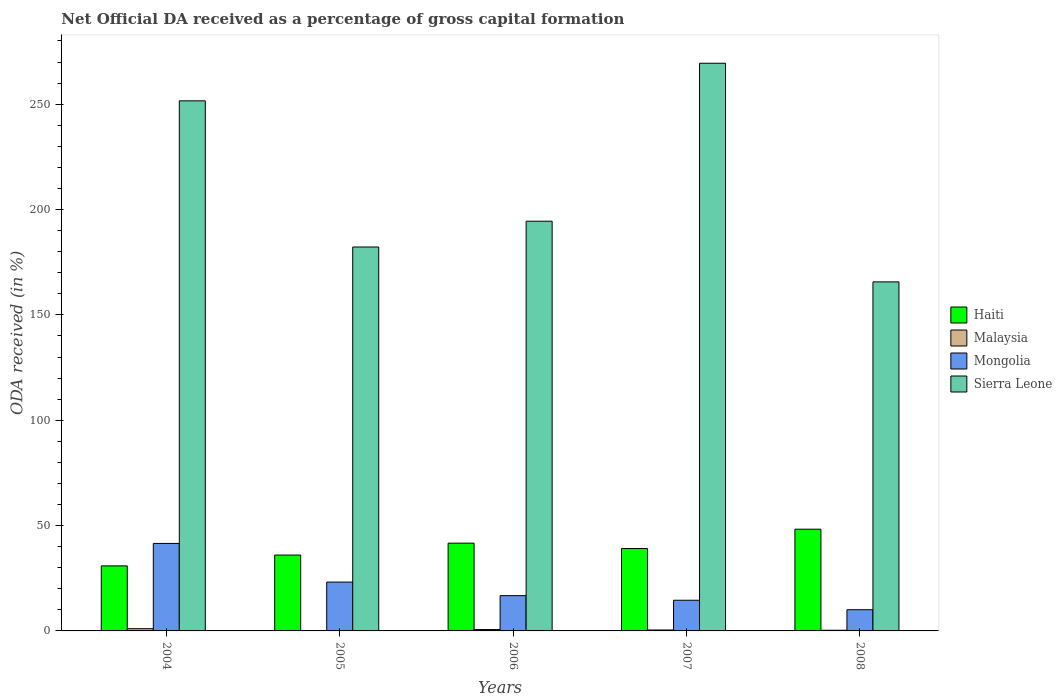How many bars are there on the 1st tick from the left?
Your response must be concise. 4. What is the label of the 3rd group of bars from the left?
Provide a succinct answer. 2006. What is the net ODA received in Mongolia in 2004?
Keep it short and to the point. 41.53. Across all years, what is the maximum net ODA received in Malaysia?
Your response must be concise. 1.06. Across all years, what is the minimum net ODA received in Malaysia?
Your response must be concise. 0.08. In which year was the net ODA received in Mongolia maximum?
Your answer should be very brief. 2004. In which year was the net ODA received in Malaysia minimum?
Provide a short and direct response. 2005. What is the total net ODA received in Sierra Leone in the graph?
Offer a terse response. 1063.39. What is the difference between the net ODA received in Malaysia in 2004 and that in 2007?
Ensure brevity in your answer.  0.62. What is the difference between the net ODA received in Malaysia in 2008 and the net ODA received in Haiti in 2004?
Give a very brief answer. -30.55. What is the average net ODA received in Sierra Leone per year?
Give a very brief answer. 212.68. In the year 2007, what is the difference between the net ODA received in Mongolia and net ODA received in Sierra Leone?
Offer a terse response. -254.87. What is the ratio of the net ODA received in Haiti in 2005 to that in 2006?
Your response must be concise. 0.86. Is the net ODA received in Malaysia in 2005 less than that in 2007?
Your response must be concise. Yes. Is the difference between the net ODA received in Mongolia in 2005 and 2006 greater than the difference between the net ODA received in Sierra Leone in 2005 and 2006?
Offer a very short reply. Yes. What is the difference between the highest and the second highest net ODA received in Haiti?
Your answer should be very brief. 6.62. What is the difference between the highest and the lowest net ODA received in Haiti?
Give a very brief answer. 17.42. In how many years, is the net ODA received in Malaysia greater than the average net ODA received in Malaysia taken over all years?
Your answer should be compact. 2. Is the sum of the net ODA received in Malaysia in 2005 and 2007 greater than the maximum net ODA received in Mongolia across all years?
Provide a short and direct response. No. What does the 2nd bar from the left in 2006 represents?
Your answer should be very brief. Malaysia. What does the 4th bar from the right in 2008 represents?
Your response must be concise. Haiti. How many bars are there?
Ensure brevity in your answer.  20. Are all the bars in the graph horizontal?
Ensure brevity in your answer.  No. What is the difference between two consecutive major ticks on the Y-axis?
Provide a succinct answer. 50. Are the values on the major ticks of Y-axis written in scientific E-notation?
Offer a very short reply. No. Does the graph contain any zero values?
Ensure brevity in your answer.  No. Does the graph contain grids?
Your answer should be very brief. No. What is the title of the graph?
Your answer should be very brief. Net Official DA received as a percentage of gross capital formation. Does "Liechtenstein" appear as one of the legend labels in the graph?
Ensure brevity in your answer.  No. What is the label or title of the Y-axis?
Make the answer very short. ODA received (in %). What is the ODA received (in %) in Haiti in 2004?
Make the answer very short. 30.87. What is the ODA received (in %) of Malaysia in 2004?
Offer a very short reply. 1.06. What is the ODA received (in %) of Mongolia in 2004?
Offer a terse response. 41.53. What is the ODA received (in %) in Sierra Leone in 2004?
Keep it short and to the point. 251.6. What is the ODA received (in %) of Haiti in 2005?
Give a very brief answer. 36.01. What is the ODA received (in %) in Malaysia in 2005?
Your answer should be very brief. 0.08. What is the ODA received (in %) of Mongolia in 2005?
Your answer should be very brief. 23.19. What is the ODA received (in %) in Sierra Leone in 2005?
Provide a succinct answer. 182.23. What is the ODA received (in %) in Haiti in 2006?
Keep it short and to the point. 41.66. What is the ODA received (in %) in Malaysia in 2006?
Your response must be concise. 0.65. What is the ODA received (in %) of Mongolia in 2006?
Your answer should be compact. 16.74. What is the ODA received (in %) of Sierra Leone in 2006?
Your response must be concise. 194.46. What is the ODA received (in %) in Haiti in 2007?
Offer a very short reply. 39.11. What is the ODA received (in %) in Malaysia in 2007?
Provide a succinct answer. 0.44. What is the ODA received (in %) in Mongolia in 2007?
Ensure brevity in your answer.  14.56. What is the ODA received (in %) of Sierra Leone in 2007?
Offer a terse response. 269.43. What is the ODA received (in %) in Haiti in 2008?
Offer a very short reply. 48.29. What is the ODA received (in %) of Malaysia in 2008?
Keep it short and to the point. 0.31. What is the ODA received (in %) of Mongolia in 2008?
Offer a terse response. 10.07. What is the ODA received (in %) in Sierra Leone in 2008?
Offer a terse response. 165.67. Across all years, what is the maximum ODA received (in %) in Haiti?
Provide a short and direct response. 48.29. Across all years, what is the maximum ODA received (in %) in Malaysia?
Give a very brief answer. 1.06. Across all years, what is the maximum ODA received (in %) in Mongolia?
Your answer should be compact. 41.53. Across all years, what is the maximum ODA received (in %) in Sierra Leone?
Offer a very short reply. 269.43. Across all years, what is the minimum ODA received (in %) of Haiti?
Provide a short and direct response. 30.87. Across all years, what is the minimum ODA received (in %) in Malaysia?
Ensure brevity in your answer.  0.08. Across all years, what is the minimum ODA received (in %) of Mongolia?
Offer a very short reply. 10.07. Across all years, what is the minimum ODA received (in %) in Sierra Leone?
Give a very brief answer. 165.67. What is the total ODA received (in %) in Haiti in the graph?
Keep it short and to the point. 195.94. What is the total ODA received (in %) of Malaysia in the graph?
Keep it short and to the point. 2.54. What is the total ODA received (in %) of Mongolia in the graph?
Ensure brevity in your answer.  106.09. What is the total ODA received (in %) of Sierra Leone in the graph?
Your answer should be very brief. 1063.39. What is the difference between the ODA received (in %) of Haiti in 2004 and that in 2005?
Ensure brevity in your answer.  -5.14. What is the difference between the ODA received (in %) of Malaysia in 2004 and that in 2005?
Give a very brief answer. 0.98. What is the difference between the ODA received (in %) in Mongolia in 2004 and that in 2005?
Provide a succinct answer. 18.34. What is the difference between the ODA received (in %) in Sierra Leone in 2004 and that in 2005?
Make the answer very short. 69.37. What is the difference between the ODA received (in %) in Haiti in 2004 and that in 2006?
Provide a short and direct response. -10.8. What is the difference between the ODA received (in %) in Malaysia in 2004 and that in 2006?
Provide a succinct answer. 0.42. What is the difference between the ODA received (in %) of Mongolia in 2004 and that in 2006?
Offer a very short reply. 24.78. What is the difference between the ODA received (in %) in Sierra Leone in 2004 and that in 2006?
Provide a succinct answer. 57.13. What is the difference between the ODA received (in %) of Haiti in 2004 and that in 2007?
Offer a very short reply. -8.24. What is the difference between the ODA received (in %) of Malaysia in 2004 and that in 2007?
Offer a terse response. 0.62. What is the difference between the ODA received (in %) of Mongolia in 2004 and that in 2007?
Make the answer very short. 26.97. What is the difference between the ODA received (in %) in Sierra Leone in 2004 and that in 2007?
Your response must be concise. -17.84. What is the difference between the ODA received (in %) in Haiti in 2004 and that in 2008?
Provide a short and direct response. -17.42. What is the difference between the ODA received (in %) in Malaysia in 2004 and that in 2008?
Offer a very short reply. 0.75. What is the difference between the ODA received (in %) of Mongolia in 2004 and that in 2008?
Your answer should be compact. 31.46. What is the difference between the ODA received (in %) of Sierra Leone in 2004 and that in 2008?
Ensure brevity in your answer.  85.93. What is the difference between the ODA received (in %) in Haiti in 2005 and that in 2006?
Your response must be concise. -5.65. What is the difference between the ODA received (in %) of Malaysia in 2005 and that in 2006?
Make the answer very short. -0.56. What is the difference between the ODA received (in %) in Mongolia in 2005 and that in 2006?
Ensure brevity in your answer.  6.44. What is the difference between the ODA received (in %) in Sierra Leone in 2005 and that in 2006?
Provide a succinct answer. -12.24. What is the difference between the ODA received (in %) of Haiti in 2005 and that in 2007?
Make the answer very short. -3.1. What is the difference between the ODA received (in %) in Malaysia in 2005 and that in 2007?
Your answer should be very brief. -0.36. What is the difference between the ODA received (in %) of Mongolia in 2005 and that in 2007?
Offer a very short reply. 8.63. What is the difference between the ODA received (in %) in Sierra Leone in 2005 and that in 2007?
Your answer should be very brief. -87.21. What is the difference between the ODA received (in %) in Haiti in 2005 and that in 2008?
Your answer should be very brief. -12.27. What is the difference between the ODA received (in %) of Malaysia in 2005 and that in 2008?
Your response must be concise. -0.23. What is the difference between the ODA received (in %) of Mongolia in 2005 and that in 2008?
Keep it short and to the point. 13.12. What is the difference between the ODA received (in %) in Sierra Leone in 2005 and that in 2008?
Provide a succinct answer. 16.56. What is the difference between the ODA received (in %) of Haiti in 2006 and that in 2007?
Make the answer very short. 2.55. What is the difference between the ODA received (in %) in Malaysia in 2006 and that in 2007?
Offer a very short reply. 0.2. What is the difference between the ODA received (in %) of Mongolia in 2006 and that in 2007?
Your answer should be very brief. 2.18. What is the difference between the ODA received (in %) in Sierra Leone in 2006 and that in 2007?
Provide a succinct answer. -74.97. What is the difference between the ODA received (in %) in Haiti in 2006 and that in 2008?
Keep it short and to the point. -6.62. What is the difference between the ODA received (in %) of Malaysia in 2006 and that in 2008?
Keep it short and to the point. 0.33. What is the difference between the ODA received (in %) of Mongolia in 2006 and that in 2008?
Your response must be concise. 6.68. What is the difference between the ODA received (in %) of Sierra Leone in 2006 and that in 2008?
Your answer should be very brief. 28.79. What is the difference between the ODA received (in %) in Haiti in 2007 and that in 2008?
Offer a terse response. -9.18. What is the difference between the ODA received (in %) in Malaysia in 2007 and that in 2008?
Give a very brief answer. 0.13. What is the difference between the ODA received (in %) in Mongolia in 2007 and that in 2008?
Your answer should be compact. 4.49. What is the difference between the ODA received (in %) of Sierra Leone in 2007 and that in 2008?
Offer a terse response. 103.76. What is the difference between the ODA received (in %) in Haiti in 2004 and the ODA received (in %) in Malaysia in 2005?
Offer a very short reply. 30.79. What is the difference between the ODA received (in %) of Haiti in 2004 and the ODA received (in %) of Mongolia in 2005?
Offer a very short reply. 7.68. What is the difference between the ODA received (in %) of Haiti in 2004 and the ODA received (in %) of Sierra Leone in 2005?
Provide a short and direct response. -151.36. What is the difference between the ODA received (in %) in Malaysia in 2004 and the ODA received (in %) in Mongolia in 2005?
Your response must be concise. -22.12. What is the difference between the ODA received (in %) of Malaysia in 2004 and the ODA received (in %) of Sierra Leone in 2005?
Make the answer very short. -181.16. What is the difference between the ODA received (in %) in Mongolia in 2004 and the ODA received (in %) in Sierra Leone in 2005?
Ensure brevity in your answer.  -140.7. What is the difference between the ODA received (in %) of Haiti in 2004 and the ODA received (in %) of Malaysia in 2006?
Make the answer very short. 30.22. What is the difference between the ODA received (in %) of Haiti in 2004 and the ODA received (in %) of Mongolia in 2006?
Make the answer very short. 14.12. What is the difference between the ODA received (in %) in Haiti in 2004 and the ODA received (in %) in Sierra Leone in 2006?
Provide a short and direct response. -163.6. What is the difference between the ODA received (in %) of Malaysia in 2004 and the ODA received (in %) of Mongolia in 2006?
Your response must be concise. -15.68. What is the difference between the ODA received (in %) in Malaysia in 2004 and the ODA received (in %) in Sierra Leone in 2006?
Your response must be concise. -193.4. What is the difference between the ODA received (in %) of Mongolia in 2004 and the ODA received (in %) of Sierra Leone in 2006?
Keep it short and to the point. -152.94. What is the difference between the ODA received (in %) of Haiti in 2004 and the ODA received (in %) of Malaysia in 2007?
Make the answer very short. 30.43. What is the difference between the ODA received (in %) of Haiti in 2004 and the ODA received (in %) of Mongolia in 2007?
Your answer should be very brief. 16.31. What is the difference between the ODA received (in %) of Haiti in 2004 and the ODA received (in %) of Sierra Leone in 2007?
Your response must be concise. -238.57. What is the difference between the ODA received (in %) of Malaysia in 2004 and the ODA received (in %) of Mongolia in 2007?
Offer a terse response. -13.5. What is the difference between the ODA received (in %) in Malaysia in 2004 and the ODA received (in %) in Sierra Leone in 2007?
Provide a short and direct response. -268.37. What is the difference between the ODA received (in %) of Mongolia in 2004 and the ODA received (in %) of Sierra Leone in 2007?
Ensure brevity in your answer.  -227.91. What is the difference between the ODA received (in %) in Haiti in 2004 and the ODA received (in %) in Malaysia in 2008?
Make the answer very short. 30.55. What is the difference between the ODA received (in %) in Haiti in 2004 and the ODA received (in %) in Mongolia in 2008?
Your response must be concise. 20.8. What is the difference between the ODA received (in %) of Haiti in 2004 and the ODA received (in %) of Sierra Leone in 2008?
Your answer should be very brief. -134.8. What is the difference between the ODA received (in %) of Malaysia in 2004 and the ODA received (in %) of Mongolia in 2008?
Keep it short and to the point. -9.01. What is the difference between the ODA received (in %) of Malaysia in 2004 and the ODA received (in %) of Sierra Leone in 2008?
Provide a short and direct response. -164.61. What is the difference between the ODA received (in %) in Mongolia in 2004 and the ODA received (in %) in Sierra Leone in 2008?
Your response must be concise. -124.14. What is the difference between the ODA received (in %) of Haiti in 2005 and the ODA received (in %) of Malaysia in 2006?
Make the answer very short. 35.37. What is the difference between the ODA received (in %) in Haiti in 2005 and the ODA received (in %) in Mongolia in 2006?
Offer a terse response. 19.27. What is the difference between the ODA received (in %) of Haiti in 2005 and the ODA received (in %) of Sierra Leone in 2006?
Keep it short and to the point. -158.45. What is the difference between the ODA received (in %) in Malaysia in 2005 and the ODA received (in %) in Mongolia in 2006?
Offer a terse response. -16.66. What is the difference between the ODA received (in %) in Malaysia in 2005 and the ODA received (in %) in Sierra Leone in 2006?
Your response must be concise. -194.38. What is the difference between the ODA received (in %) of Mongolia in 2005 and the ODA received (in %) of Sierra Leone in 2006?
Offer a very short reply. -171.28. What is the difference between the ODA received (in %) in Haiti in 2005 and the ODA received (in %) in Malaysia in 2007?
Ensure brevity in your answer.  35.57. What is the difference between the ODA received (in %) in Haiti in 2005 and the ODA received (in %) in Mongolia in 2007?
Offer a very short reply. 21.45. What is the difference between the ODA received (in %) in Haiti in 2005 and the ODA received (in %) in Sierra Leone in 2007?
Your response must be concise. -233.42. What is the difference between the ODA received (in %) in Malaysia in 2005 and the ODA received (in %) in Mongolia in 2007?
Make the answer very short. -14.48. What is the difference between the ODA received (in %) in Malaysia in 2005 and the ODA received (in %) in Sierra Leone in 2007?
Provide a succinct answer. -269.35. What is the difference between the ODA received (in %) in Mongolia in 2005 and the ODA received (in %) in Sierra Leone in 2007?
Offer a very short reply. -246.25. What is the difference between the ODA received (in %) of Haiti in 2005 and the ODA received (in %) of Malaysia in 2008?
Offer a terse response. 35.7. What is the difference between the ODA received (in %) in Haiti in 2005 and the ODA received (in %) in Mongolia in 2008?
Provide a short and direct response. 25.94. What is the difference between the ODA received (in %) of Haiti in 2005 and the ODA received (in %) of Sierra Leone in 2008?
Make the answer very short. -129.66. What is the difference between the ODA received (in %) in Malaysia in 2005 and the ODA received (in %) in Mongolia in 2008?
Make the answer very short. -9.99. What is the difference between the ODA received (in %) in Malaysia in 2005 and the ODA received (in %) in Sierra Leone in 2008?
Provide a succinct answer. -165.59. What is the difference between the ODA received (in %) of Mongolia in 2005 and the ODA received (in %) of Sierra Leone in 2008?
Keep it short and to the point. -142.48. What is the difference between the ODA received (in %) of Haiti in 2006 and the ODA received (in %) of Malaysia in 2007?
Provide a short and direct response. 41.22. What is the difference between the ODA received (in %) in Haiti in 2006 and the ODA received (in %) in Mongolia in 2007?
Your response must be concise. 27.1. What is the difference between the ODA received (in %) of Haiti in 2006 and the ODA received (in %) of Sierra Leone in 2007?
Give a very brief answer. -227.77. What is the difference between the ODA received (in %) of Malaysia in 2006 and the ODA received (in %) of Mongolia in 2007?
Offer a very short reply. -13.91. What is the difference between the ODA received (in %) of Malaysia in 2006 and the ODA received (in %) of Sierra Leone in 2007?
Provide a succinct answer. -268.79. What is the difference between the ODA received (in %) of Mongolia in 2006 and the ODA received (in %) of Sierra Leone in 2007?
Provide a succinct answer. -252.69. What is the difference between the ODA received (in %) of Haiti in 2006 and the ODA received (in %) of Malaysia in 2008?
Provide a succinct answer. 41.35. What is the difference between the ODA received (in %) of Haiti in 2006 and the ODA received (in %) of Mongolia in 2008?
Your answer should be compact. 31.59. What is the difference between the ODA received (in %) in Haiti in 2006 and the ODA received (in %) in Sierra Leone in 2008?
Your answer should be very brief. -124.01. What is the difference between the ODA received (in %) in Malaysia in 2006 and the ODA received (in %) in Mongolia in 2008?
Provide a short and direct response. -9.42. What is the difference between the ODA received (in %) in Malaysia in 2006 and the ODA received (in %) in Sierra Leone in 2008?
Ensure brevity in your answer.  -165.02. What is the difference between the ODA received (in %) of Mongolia in 2006 and the ODA received (in %) of Sierra Leone in 2008?
Your answer should be compact. -148.92. What is the difference between the ODA received (in %) of Haiti in 2007 and the ODA received (in %) of Malaysia in 2008?
Give a very brief answer. 38.8. What is the difference between the ODA received (in %) in Haiti in 2007 and the ODA received (in %) in Mongolia in 2008?
Provide a short and direct response. 29.04. What is the difference between the ODA received (in %) in Haiti in 2007 and the ODA received (in %) in Sierra Leone in 2008?
Provide a succinct answer. -126.56. What is the difference between the ODA received (in %) in Malaysia in 2007 and the ODA received (in %) in Mongolia in 2008?
Your response must be concise. -9.63. What is the difference between the ODA received (in %) of Malaysia in 2007 and the ODA received (in %) of Sierra Leone in 2008?
Offer a very short reply. -165.23. What is the difference between the ODA received (in %) of Mongolia in 2007 and the ODA received (in %) of Sierra Leone in 2008?
Make the answer very short. -151.11. What is the average ODA received (in %) of Haiti per year?
Your response must be concise. 39.19. What is the average ODA received (in %) of Malaysia per year?
Offer a terse response. 0.51. What is the average ODA received (in %) of Mongolia per year?
Keep it short and to the point. 21.22. What is the average ODA received (in %) in Sierra Leone per year?
Your answer should be compact. 212.68. In the year 2004, what is the difference between the ODA received (in %) of Haiti and ODA received (in %) of Malaysia?
Offer a very short reply. 29.8. In the year 2004, what is the difference between the ODA received (in %) of Haiti and ODA received (in %) of Mongolia?
Provide a succinct answer. -10.66. In the year 2004, what is the difference between the ODA received (in %) in Haiti and ODA received (in %) in Sierra Leone?
Your answer should be compact. -220.73. In the year 2004, what is the difference between the ODA received (in %) in Malaysia and ODA received (in %) in Mongolia?
Your response must be concise. -40.46. In the year 2004, what is the difference between the ODA received (in %) of Malaysia and ODA received (in %) of Sierra Leone?
Give a very brief answer. -250.53. In the year 2004, what is the difference between the ODA received (in %) of Mongolia and ODA received (in %) of Sierra Leone?
Make the answer very short. -210.07. In the year 2005, what is the difference between the ODA received (in %) of Haiti and ODA received (in %) of Malaysia?
Offer a terse response. 35.93. In the year 2005, what is the difference between the ODA received (in %) of Haiti and ODA received (in %) of Mongolia?
Offer a terse response. 12.82. In the year 2005, what is the difference between the ODA received (in %) of Haiti and ODA received (in %) of Sierra Leone?
Provide a succinct answer. -146.21. In the year 2005, what is the difference between the ODA received (in %) in Malaysia and ODA received (in %) in Mongolia?
Provide a short and direct response. -23.11. In the year 2005, what is the difference between the ODA received (in %) of Malaysia and ODA received (in %) of Sierra Leone?
Your response must be concise. -182.14. In the year 2005, what is the difference between the ODA received (in %) in Mongolia and ODA received (in %) in Sierra Leone?
Ensure brevity in your answer.  -159.04. In the year 2006, what is the difference between the ODA received (in %) in Haiti and ODA received (in %) in Malaysia?
Your response must be concise. 41.02. In the year 2006, what is the difference between the ODA received (in %) in Haiti and ODA received (in %) in Mongolia?
Your answer should be compact. 24.92. In the year 2006, what is the difference between the ODA received (in %) of Haiti and ODA received (in %) of Sierra Leone?
Your answer should be very brief. -152.8. In the year 2006, what is the difference between the ODA received (in %) of Malaysia and ODA received (in %) of Mongolia?
Offer a terse response. -16.1. In the year 2006, what is the difference between the ODA received (in %) in Malaysia and ODA received (in %) in Sierra Leone?
Give a very brief answer. -193.82. In the year 2006, what is the difference between the ODA received (in %) of Mongolia and ODA received (in %) of Sierra Leone?
Make the answer very short. -177.72. In the year 2007, what is the difference between the ODA received (in %) of Haiti and ODA received (in %) of Malaysia?
Give a very brief answer. 38.67. In the year 2007, what is the difference between the ODA received (in %) of Haiti and ODA received (in %) of Mongolia?
Offer a very short reply. 24.55. In the year 2007, what is the difference between the ODA received (in %) in Haiti and ODA received (in %) in Sierra Leone?
Ensure brevity in your answer.  -230.32. In the year 2007, what is the difference between the ODA received (in %) of Malaysia and ODA received (in %) of Mongolia?
Make the answer very short. -14.12. In the year 2007, what is the difference between the ODA received (in %) of Malaysia and ODA received (in %) of Sierra Leone?
Offer a very short reply. -268.99. In the year 2007, what is the difference between the ODA received (in %) of Mongolia and ODA received (in %) of Sierra Leone?
Your response must be concise. -254.87. In the year 2008, what is the difference between the ODA received (in %) of Haiti and ODA received (in %) of Malaysia?
Provide a succinct answer. 47.97. In the year 2008, what is the difference between the ODA received (in %) of Haiti and ODA received (in %) of Mongolia?
Your answer should be very brief. 38.22. In the year 2008, what is the difference between the ODA received (in %) in Haiti and ODA received (in %) in Sierra Leone?
Offer a terse response. -117.38. In the year 2008, what is the difference between the ODA received (in %) in Malaysia and ODA received (in %) in Mongolia?
Give a very brief answer. -9.76. In the year 2008, what is the difference between the ODA received (in %) in Malaysia and ODA received (in %) in Sierra Leone?
Ensure brevity in your answer.  -165.36. In the year 2008, what is the difference between the ODA received (in %) of Mongolia and ODA received (in %) of Sierra Leone?
Your answer should be very brief. -155.6. What is the ratio of the ODA received (in %) in Malaysia in 2004 to that in 2005?
Make the answer very short. 13.07. What is the ratio of the ODA received (in %) of Mongolia in 2004 to that in 2005?
Keep it short and to the point. 1.79. What is the ratio of the ODA received (in %) in Sierra Leone in 2004 to that in 2005?
Provide a succinct answer. 1.38. What is the ratio of the ODA received (in %) of Haiti in 2004 to that in 2006?
Give a very brief answer. 0.74. What is the ratio of the ODA received (in %) of Malaysia in 2004 to that in 2006?
Your response must be concise. 1.65. What is the ratio of the ODA received (in %) in Mongolia in 2004 to that in 2006?
Keep it short and to the point. 2.48. What is the ratio of the ODA received (in %) of Sierra Leone in 2004 to that in 2006?
Provide a succinct answer. 1.29. What is the ratio of the ODA received (in %) of Haiti in 2004 to that in 2007?
Offer a terse response. 0.79. What is the ratio of the ODA received (in %) in Malaysia in 2004 to that in 2007?
Ensure brevity in your answer.  2.41. What is the ratio of the ODA received (in %) in Mongolia in 2004 to that in 2007?
Make the answer very short. 2.85. What is the ratio of the ODA received (in %) in Sierra Leone in 2004 to that in 2007?
Ensure brevity in your answer.  0.93. What is the ratio of the ODA received (in %) in Haiti in 2004 to that in 2008?
Your answer should be compact. 0.64. What is the ratio of the ODA received (in %) in Malaysia in 2004 to that in 2008?
Provide a short and direct response. 3.41. What is the ratio of the ODA received (in %) in Mongolia in 2004 to that in 2008?
Provide a succinct answer. 4.12. What is the ratio of the ODA received (in %) in Sierra Leone in 2004 to that in 2008?
Ensure brevity in your answer.  1.52. What is the ratio of the ODA received (in %) of Haiti in 2005 to that in 2006?
Your answer should be very brief. 0.86. What is the ratio of the ODA received (in %) in Malaysia in 2005 to that in 2006?
Your answer should be very brief. 0.13. What is the ratio of the ODA received (in %) of Mongolia in 2005 to that in 2006?
Offer a terse response. 1.38. What is the ratio of the ODA received (in %) in Sierra Leone in 2005 to that in 2006?
Provide a short and direct response. 0.94. What is the ratio of the ODA received (in %) in Haiti in 2005 to that in 2007?
Give a very brief answer. 0.92. What is the ratio of the ODA received (in %) in Malaysia in 2005 to that in 2007?
Make the answer very short. 0.18. What is the ratio of the ODA received (in %) of Mongolia in 2005 to that in 2007?
Offer a very short reply. 1.59. What is the ratio of the ODA received (in %) in Sierra Leone in 2005 to that in 2007?
Your response must be concise. 0.68. What is the ratio of the ODA received (in %) of Haiti in 2005 to that in 2008?
Provide a short and direct response. 0.75. What is the ratio of the ODA received (in %) of Malaysia in 2005 to that in 2008?
Offer a terse response. 0.26. What is the ratio of the ODA received (in %) of Mongolia in 2005 to that in 2008?
Ensure brevity in your answer.  2.3. What is the ratio of the ODA received (in %) in Sierra Leone in 2005 to that in 2008?
Your response must be concise. 1.1. What is the ratio of the ODA received (in %) in Haiti in 2006 to that in 2007?
Your response must be concise. 1.07. What is the ratio of the ODA received (in %) of Malaysia in 2006 to that in 2007?
Your response must be concise. 1.46. What is the ratio of the ODA received (in %) in Mongolia in 2006 to that in 2007?
Provide a short and direct response. 1.15. What is the ratio of the ODA received (in %) in Sierra Leone in 2006 to that in 2007?
Provide a short and direct response. 0.72. What is the ratio of the ODA received (in %) in Haiti in 2006 to that in 2008?
Offer a very short reply. 0.86. What is the ratio of the ODA received (in %) of Malaysia in 2006 to that in 2008?
Provide a short and direct response. 2.07. What is the ratio of the ODA received (in %) in Mongolia in 2006 to that in 2008?
Offer a very short reply. 1.66. What is the ratio of the ODA received (in %) of Sierra Leone in 2006 to that in 2008?
Ensure brevity in your answer.  1.17. What is the ratio of the ODA received (in %) in Haiti in 2007 to that in 2008?
Offer a terse response. 0.81. What is the ratio of the ODA received (in %) of Malaysia in 2007 to that in 2008?
Your answer should be very brief. 1.42. What is the ratio of the ODA received (in %) of Mongolia in 2007 to that in 2008?
Your answer should be compact. 1.45. What is the ratio of the ODA received (in %) of Sierra Leone in 2007 to that in 2008?
Offer a very short reply. 1.63. What is the difference between the highest and the second highest ODA received (in %) of Haiti?
Offer a very short reply. 6.62. What is the difference between the highest and the second highest ODA received (in %) in Malaysia?
Your response must be concise. 0.42. What is the difference between the highest and the second highest ODA received (in %) of Mongolia?
Your response must be concise. 18.34. What is the difference between the highest and the second highest ODA received (in %) of Sierra Leone?
Provide a succinct answer. 17.84. What is the difference between the highest and the lowest ODA received (in %) of Haiti?
Your answer should be very brief. 17.42. What is the difference between the highest and the lowest ODA received (in %) in Malaysia?
Provide a succinct answer. 0.98. What is the difference between the highest and the lowest ODA received (in %) of Mongolia?
Your answer should be very brief. 31.46. What is the difference between the highest and the lowest ODA received (in %) in Sierra Leone?
Your answer should be very brief. 103.76. 